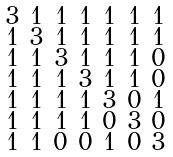<formula> <loc_0><loc_0><loc_500><loc_500>\begin{smallmatrix} 3 & 1 & 1 & 1 & 1 & 1 & 1 \\ 1 & 3 & 1 & 1 & 1 & 1 & 1 \\ 1 & 1 & 3 & 1 & 1 & 1 & 0 \\ 1 & 1 & 1 & 3 & 1 & 1 & 0 \\ 1 & 1 & 1 & 1 & 3 & 0 & 1 \\ 1 & 1 & 1 & 1 & 0 & 3 & 0 \\ 1 & 1 & 0 & 0 & 1 & 0 & 3 \end{smallmatrix}</formula> 